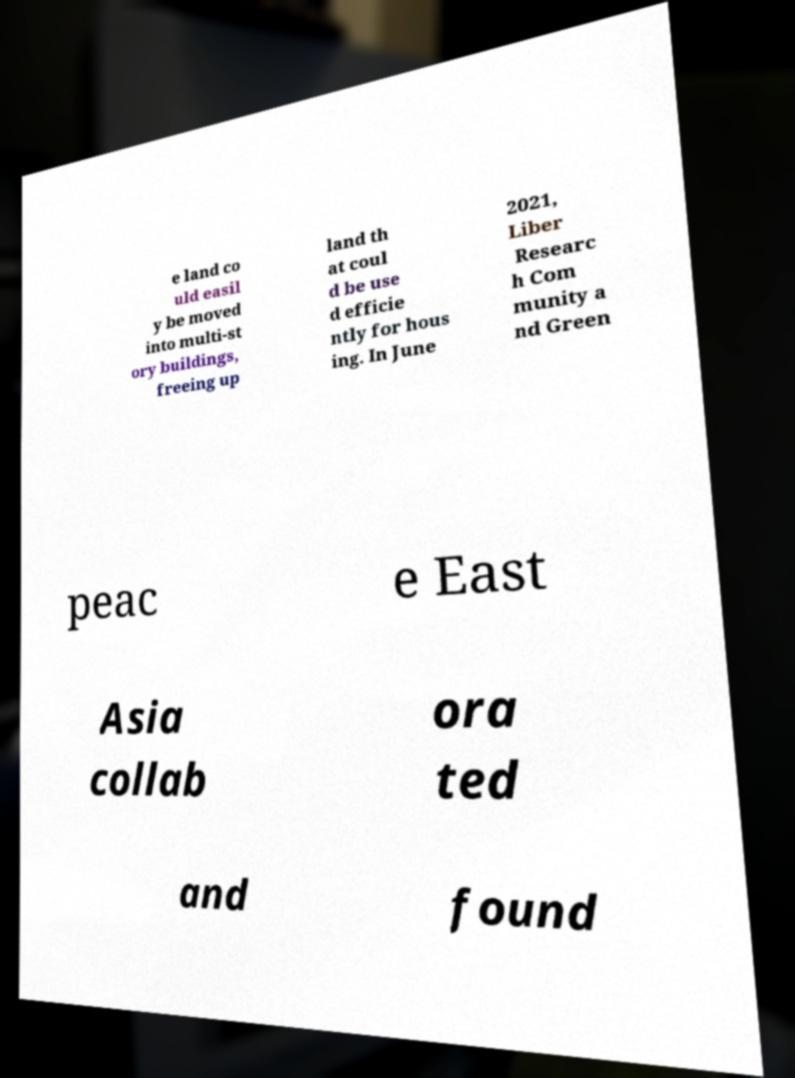Can you accurately transcribe the text from the provided image for me? e land co uld easil y be moved into multi-st ory buildings, freeing up land th at coul d be use d efficie ntly for hous ing. In June 2021, Liber Researc h Com munity a nd Green peac e East Asia collab ora ted and found 